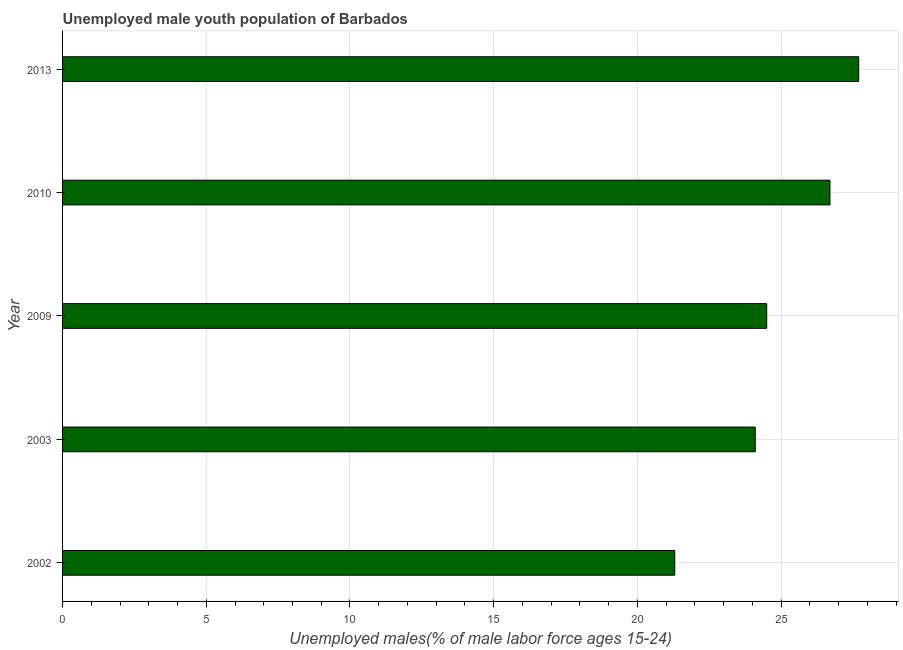Does the graph contain any zero values?
Offer a terse response. No. What is the title of the graph?
Offer a terse response. Unemployed male youth population of Barbados. What is the label or title of the X-axis?
Offer a very short reply. Unemployed males(% of male labor force ages 15-24). What is the label or title of the Y-axis?
Ensure brevity in your answer.  Year. Across all years, what is the maximum unemployed male youth?
Your answer should be compact. 27.7. Across all years, what is the minimum unemployed male youth?
Provide a succinct answer. 21.3. In which year was the unemployed male youth maximum?
Ensure brevity in your answer.  2013. In which year was the unemployed male youth minimum?
Your answer should be compact. 2002. What is the sum of the unemployed male youth?
Your answer should be very brief. 124.3. What is the average unemployed male youth per year?
Your answer should be very brief. 24.86. In how many years, is the unemployed male youth greater than 2 %?
Your answer should be compact. 5. Do a majority of the years between 2009 and 2013 (inclusive) have unemployed male youth greater than 14 %?
Give a very brief answer. Yes. What is the ratio of the unemployed male youth in 2002 to that in 2013?
Keep it short and to the point. 0.77. Is the unemployed male youth in 2002 less than that in 2013?
Give a very brief answer. Yes. What is the difference between the highest and the second highest unemployed male youth?
Your answer should be very brief. 1. Is the sum of the unemployed male youth in 2003 and 2013 greater than the maximum unemployed male youth across all years?
Offer a very short reply. Yes. What is the difference between the highest and the lowest unemployed male youth?
Offer a very short reply. 6.4. How many years are there in the graph?
Ensure brevity in your answer.  5. What is the difference between two consecutive major ticks on the X-axis?
Your answer should be compact. 5. What is the Unemployed males(% of male labor force ages 15-24) in 2002?
Keep it short and to the point. 21.3. What is the Unemployed males(% of male labor force ages 15-24) of 2003?
Make the answer very short. 24.1. What is the Unemployed males(% of male labor force ages 15-24) of 2009?
Offer a very short reply. 24.5. What is the Unemployed males(% of male labor force ages 15-24) in 2010?
Offer a terse response. 26.7. What is the Unemployed males(% of male labor force ages 15-24) in 2013?
Ensure brevity in your answer.  27.7. What is the difference between the Unemployed males(% of male labor force ages 15-24) in 2003 and 2009?
Your response must be concise. -0.4. What is the difference between the Unemployed males(% of male labor force ages 15-24) in 2003 and 2013?
Keep it short and to the point. -3.6. What is the difference between the Unemployed males(% of male labor force ages 15-24) in 2010 and 2013?
Your answer should be very brief. -1. What is the ratio of the Unemployed males(% of male labor force ages 15-24) in 2002 to that in 2003?
Make the answer very short. 0.88. What is the ratio of the Unemployed males(% of male labor force ages 15-24) in 2002 to that in 2009?
Provide a succinct answer. 0.87. What is the ratio of the Unemployed males(% of male labor force ages 15-24) in 2002 to that in 2010?
Make the answer very short. 0.8. What is the ratio of the Unemployed males(% of male labor force ages 15-24) in 2002 to that in 2013?
Keep it short and to the point. 0.77. What is the ratio of the Unemployed males(% of male labor force ages 15-24) in 2003 to that in 2009?
Give a very brief answer. 0.98. What is the ratio of the Unemployed males(% of male labor force ages 15-24) in 2003 to that in 2010?
Offer a terse response. 0.9. What is the ratio of the Unemployed males(% of male labor force ages 15-24) in 2003 to that in 2013?
Offer a terse response. 0.87. What is the ratio of the Unemployed males(% of male labor force ages 15-24) in 2009 to that in 2010?
Provide a succinct answer. 0.92. What is the ratio of the Unemployed males(% of male labor force ages 15-24) in 2009 to that in 2013?
Provide a succinct answer. 0.88. 